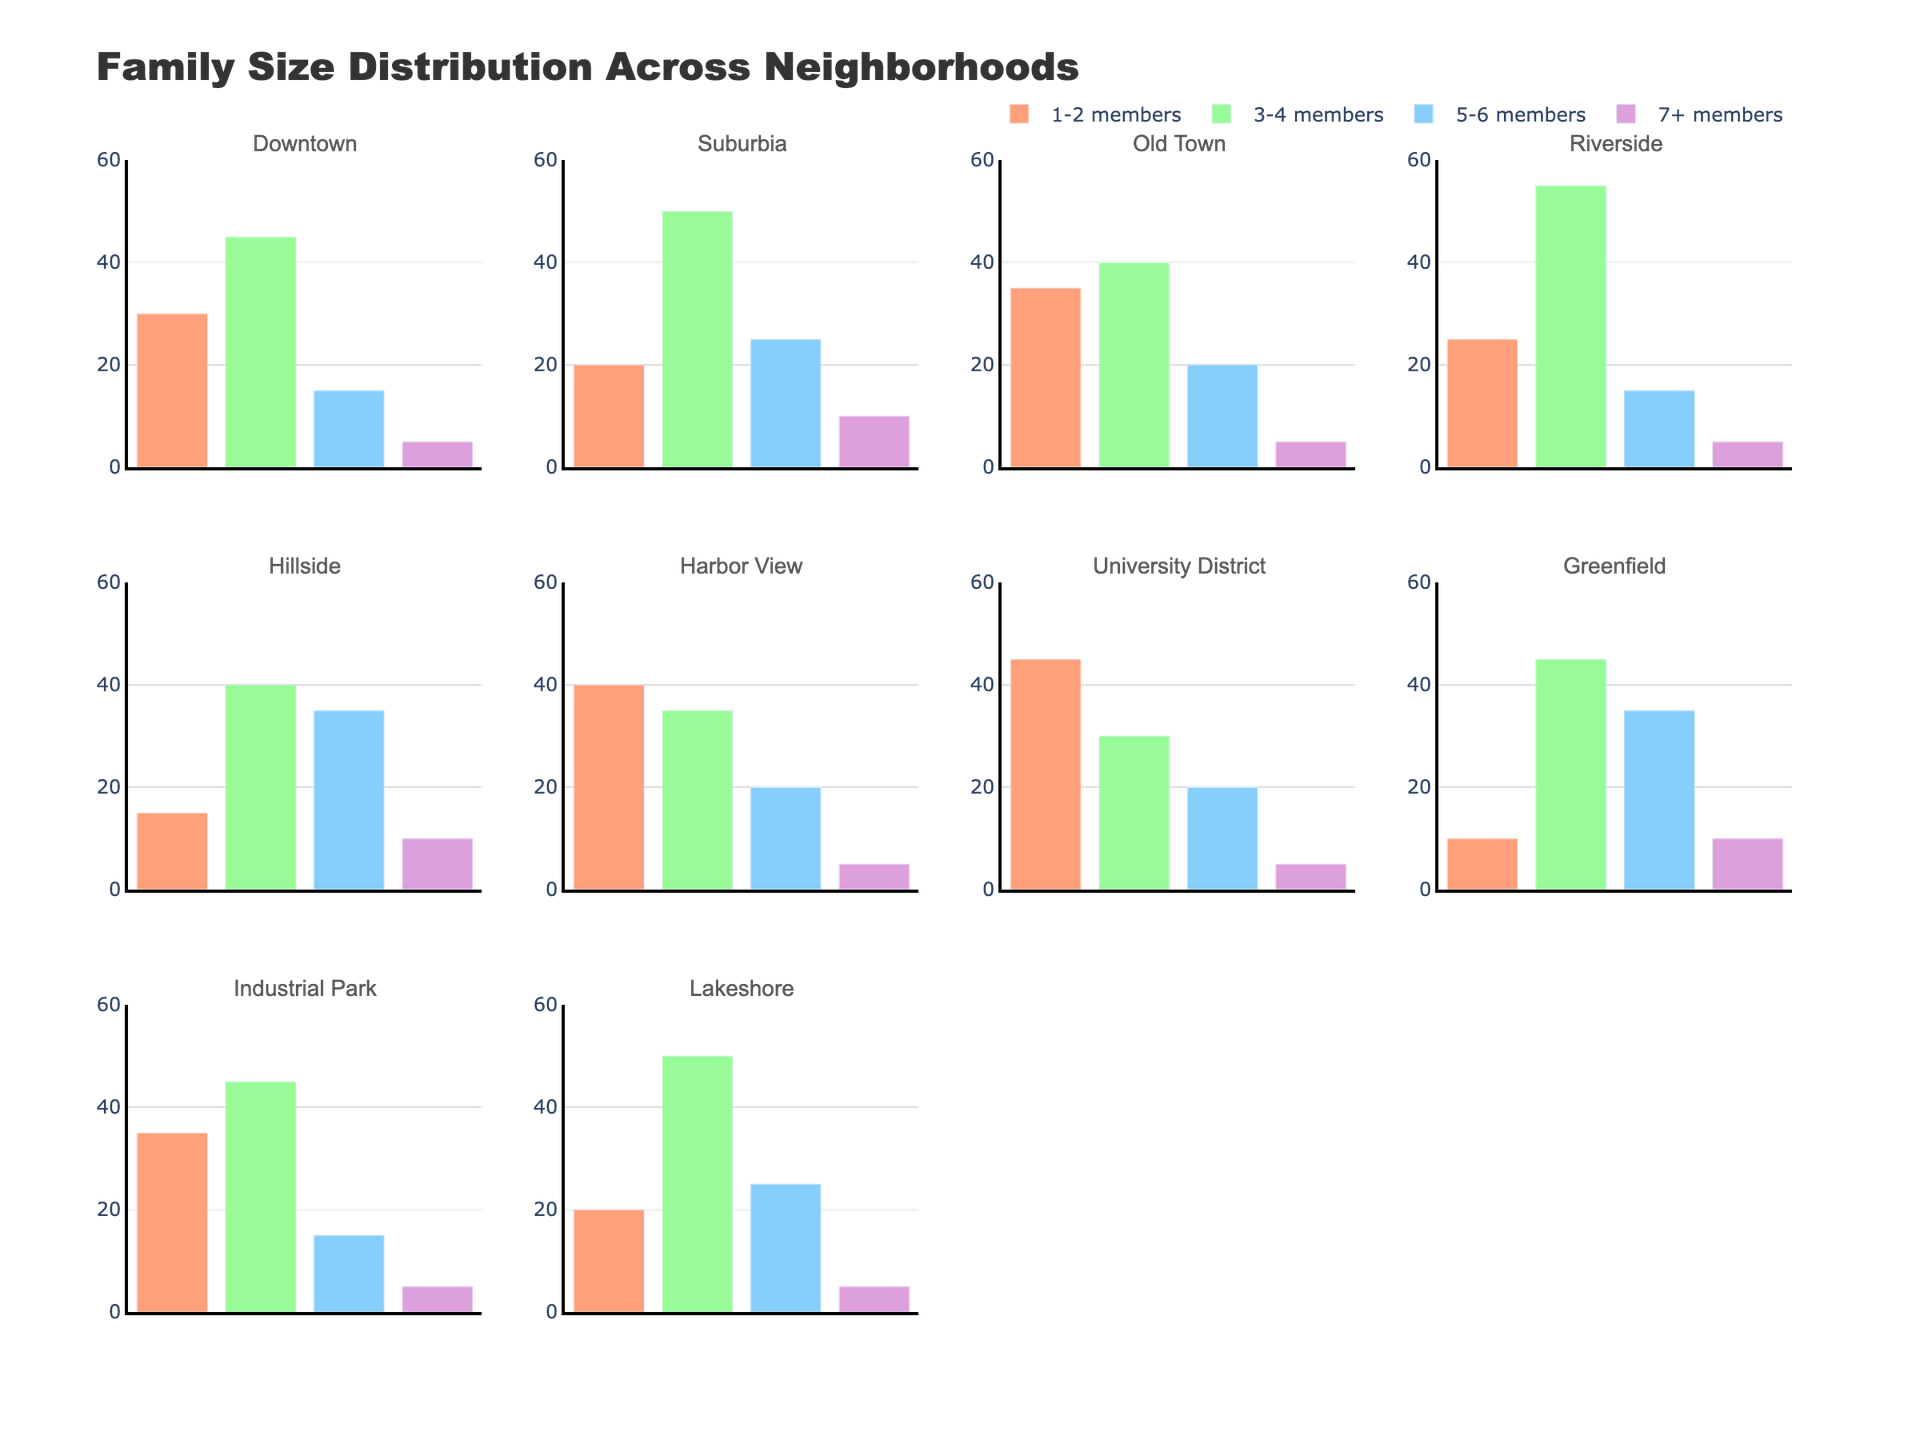What is the family size category with the highest number of families in the Downtown neighborhood? To find this, look at the bar heights in the Downtown subplot. The category with the highest bar represents the most common family size. The '3-4 members' bar is the highest with 45 families.
Answer: 3-4 members How many families in Riverside have either 1-2 members or 7+ members? In the Riverside subplot, sum the number of families for '1-2 members' (25) and '7+ members' (5). Therefore, 25 + 5 = 30 families.
Answer: 30 Which neighborhood has the smallest number of families with 1-2 members? Compare the height of the '1-2 members' bar across all subplots. Greenfield has the smallest bar at 10 families.
Answer: Greenfield What is the total number of families with 5-6 members in both Suburbia and Hillside neighborhoods? Add the number of families in 5-6 members category from both Suburbia (25) and Hillside (35). So, 25 + 35 = 60 families.
Answer: 60 Which neighborhoods have exactly 5 families with 7+ members? Identify neighborhoods with a bar height of 5 for the '7+ members' category. Downtown, Old Town, Riverside, Harbor View, University District, and Industrial Park each have 5 families.
Answer: Downtown, Old Town, Riverside, Harbor View, University District, Industrial Park In which neighborhood is the distribution of family sizes most balanced? To determine balance, look for the subplot with bars of similar height across all categories. Harbor View has the most balanced distribution, with family sizes of 40, 35, 20, and 5.
Answer: Harbor View Which neighborhood has the highest total number of families across all family size categories? Sum the values of each family size category for each neighborhood and compare the total numbers. Riverside has the highest total with 25+55+15+5 = 100 families.
Answer: Riverside How many more 3-4 member families does Lakeshore have compared to Hillside? Subtract the number of 3-4 member families in Hillside (40) from that in Lakeshore (50). So, 50 - 40 = 10 families.
Answer: 10 What is the average number of 7+ member families across all neighborhoods? Sum the number of 7+ member families across all neighborhoods and divide by the number of neighborhoods. The sum is 5+10+5+5+10+5+5+10+5+5 = 65 and there are 10 neighborhoods. Therefore, 65 / 10 = 6.5 families.
Answer: 6.5 